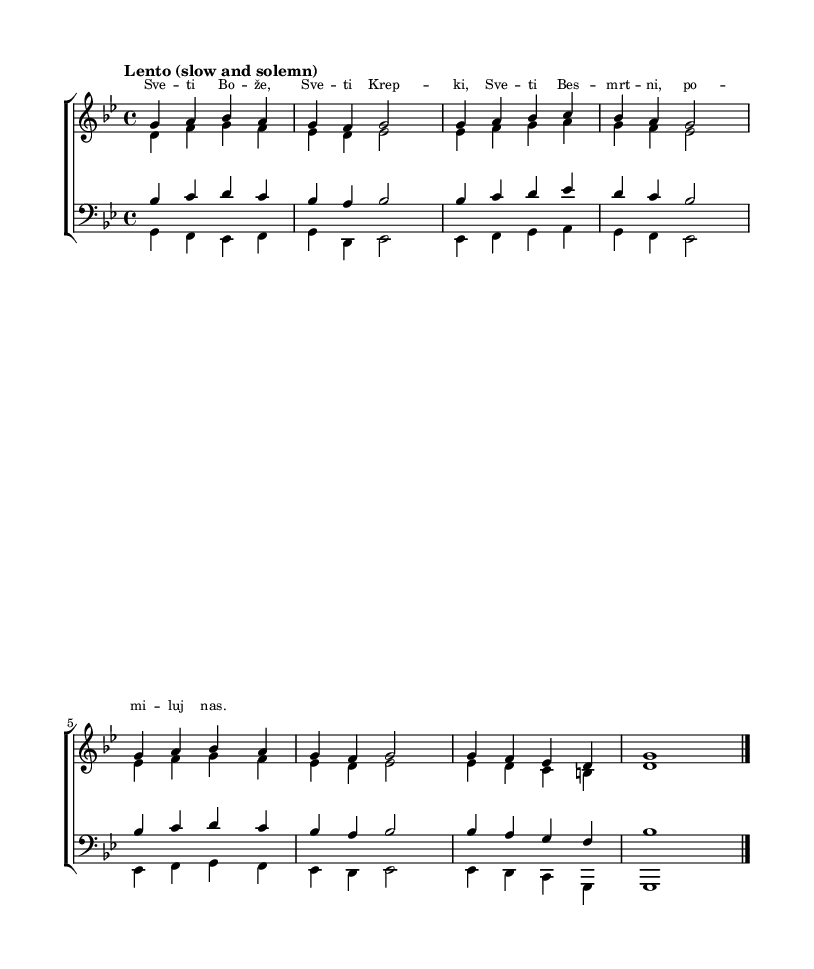What is the key signature of this music? The key signature is G minor, which has two flats (B flat and E flat). This can be identified at the beginning of the score, where the key signature is indicated.
Answer: G minor What is the time signature of this music? The time signature is 4/4, which means there are four beats in each measure and the quarter note gets one beat. This is indicated at the beginning of the score next to the key signature.
Answer: 4/4 What is the tempo marking of this piece? The tempo marking of the piece is "Lento," which indicates that the music should be played slowly and solemnly. This is found in the tempo indication near the beginning of the score.
Answer: Lento How many voices are present in this hymn? There are four voices in this hymn: soprano, alto, tenor, and bass, indicated by the separate staves for each voice type in the score.
Answer: Four What are the lyrics of the first line? The lyrics of the first line are "Sve ti Bože," which starts off the hymn as indicated below the soprano staff in the score.
Answer: Sve ti Bože Which voice holds the melody in this hymn? The soprano voice holds the melody in this hymn, as it typically sings the highest line and is often the main melodic voice in choral settings. This can be seen from the musical line and its placement on the staff.
Answer: Soprano 